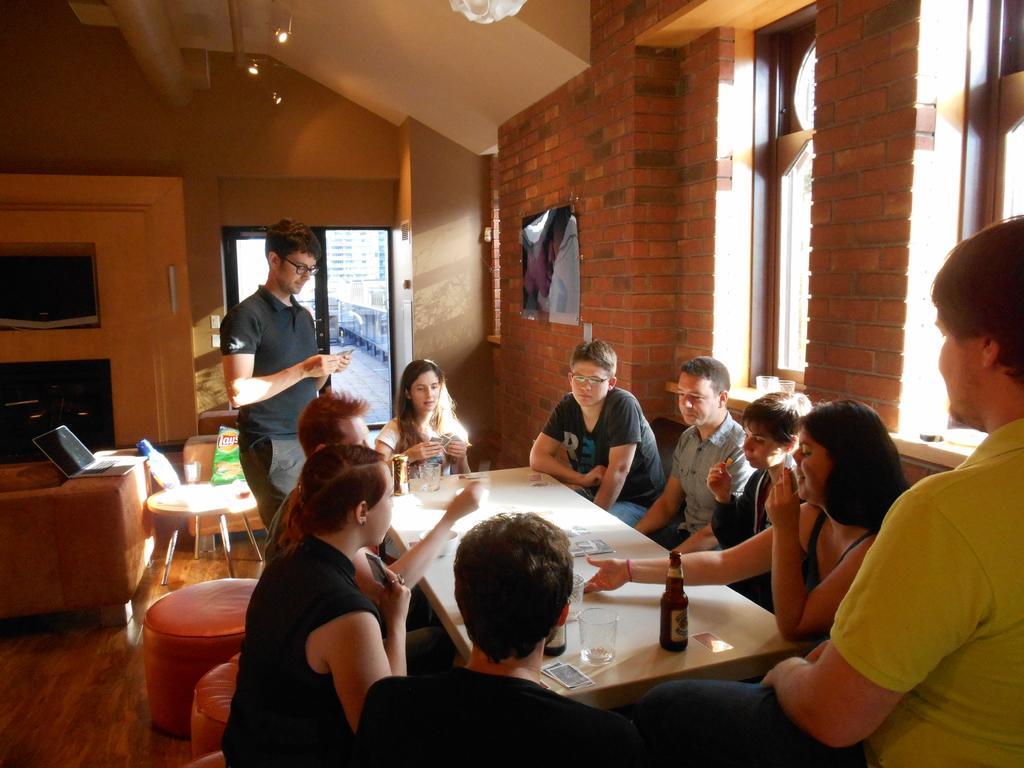How would you summarize this image in a sentence or two? In this image we can see a group of people who are sitting on a sofa and they are playing cards. This is a table where a beer bottle and glasses and cards are kept on it. Here we can see a laptop which is placed on this sofa. Here we can see a window and this is a glass door. 